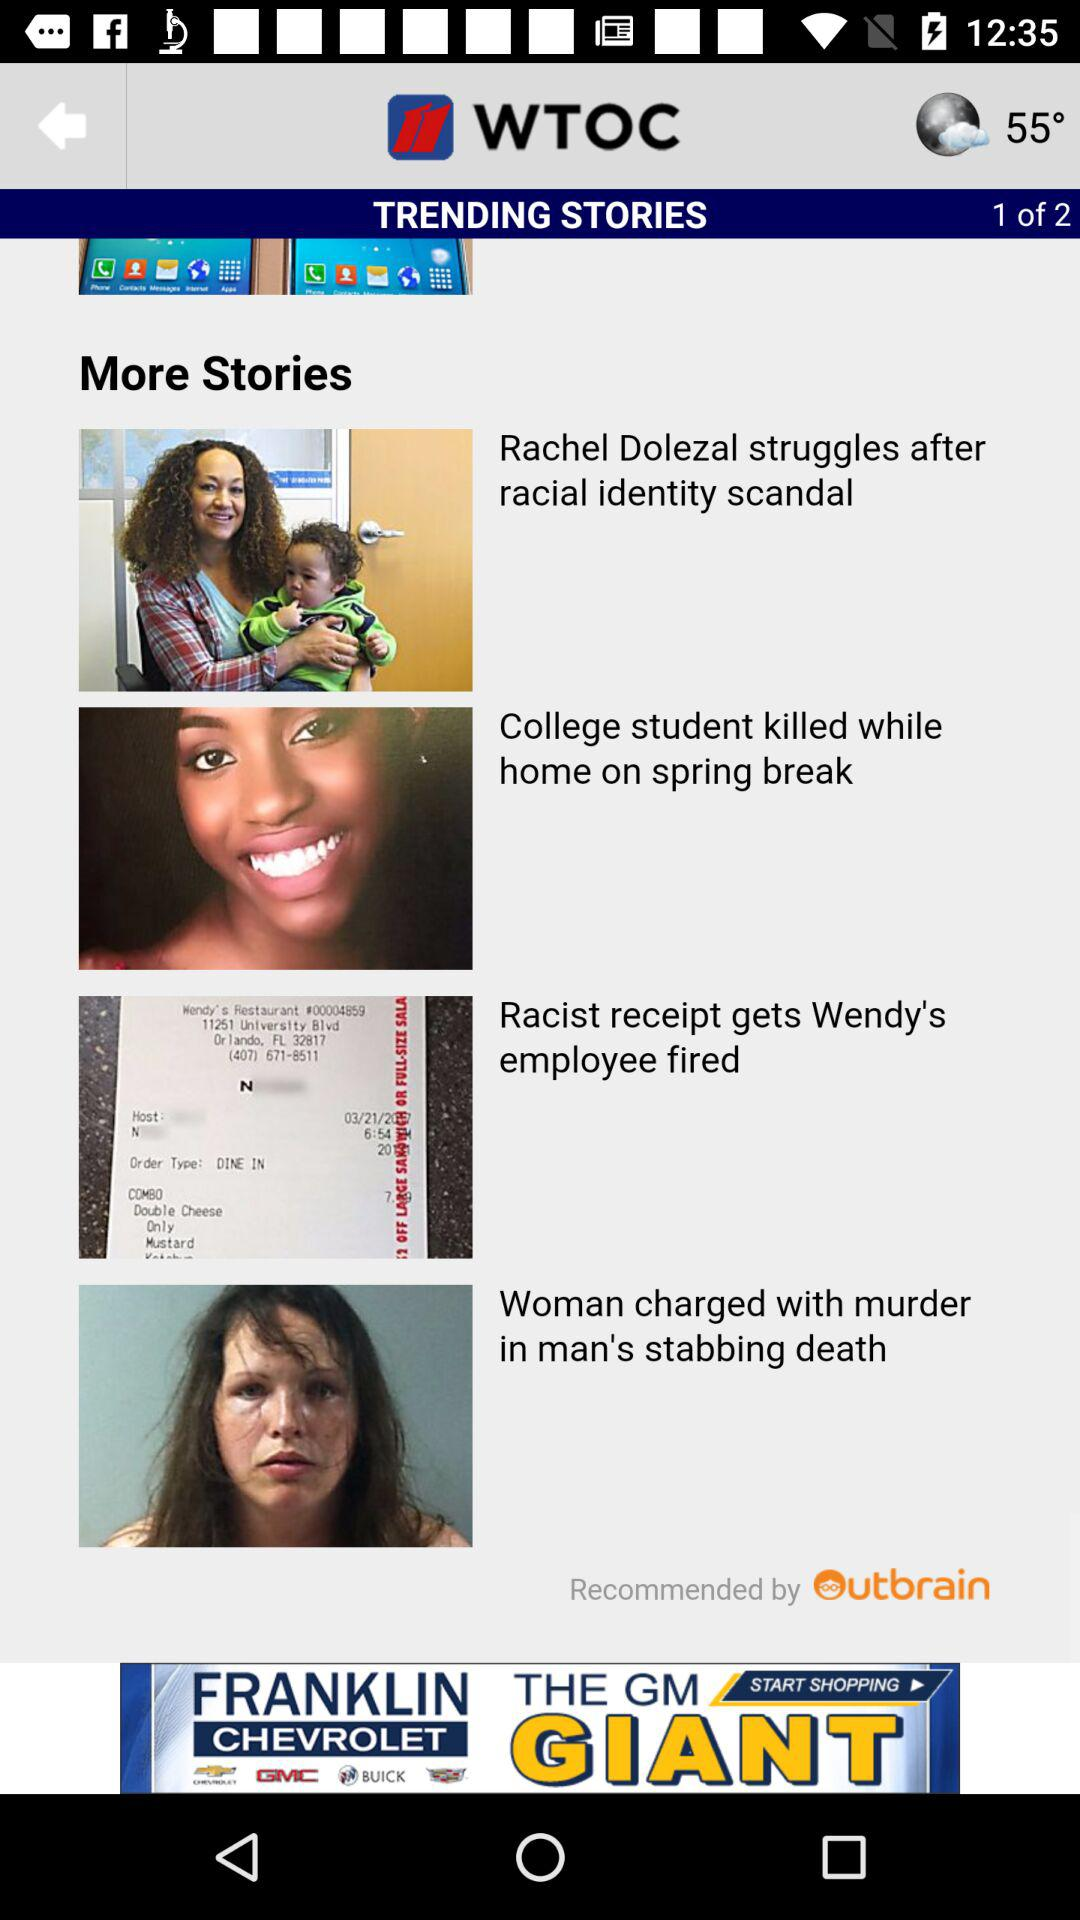Currently, we are on which page number? You are on page number 1. 